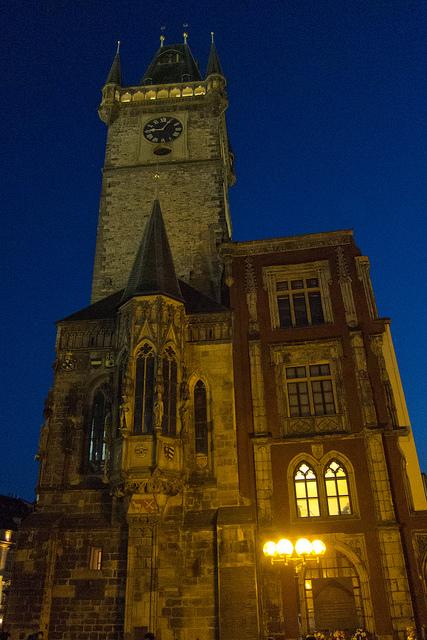Is it getting dark outside?
Concise answer only. Yes. Are there clouds?
Be succinct. No. Is there a clock in this picture?
Keep it brief. Yes. Is there a clock in the tower?
Give a very brief answer. Yes. What time does the clock mark?
Answer briefly. 9:05. Is the building new?
Be succinct. No. Is this an old hotel?
Answer briefly. Yes. Are there any street lights in front of the building?
Quick response, please. Yes. 